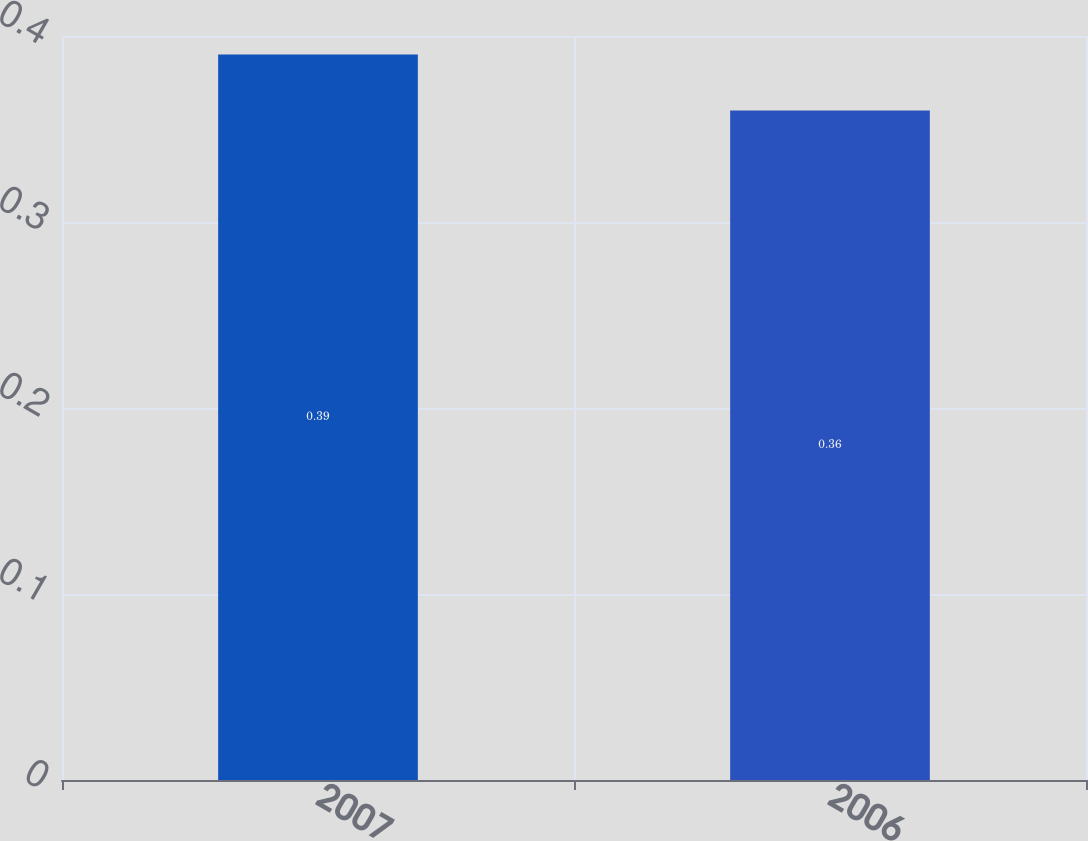Convert chart to OTSL. <chart><loc_0><loc_0><loc_500><loc_500><bar_chart><fcel>2007<fcel>2006<nl><fcel>0.39<fcel>0.36<nl></chart> 